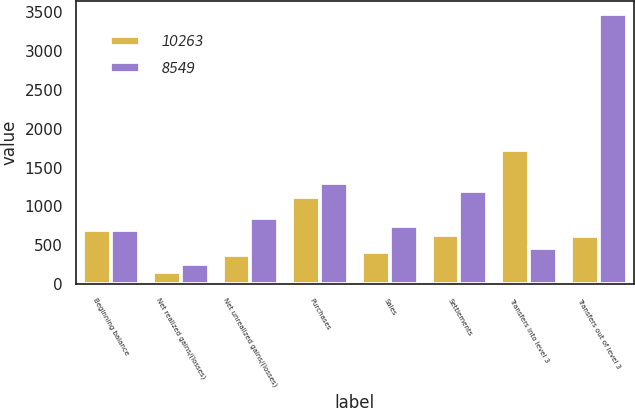Convert chart to OTSL. <chart><loc_0><loc_0><loc_500><loc_500><stacked_bar_chart><ecel><fcel>Beginning balance<fcel>Net realized gains/(losses)<fcel>Net unrealized gains/(losses)<fcel>Purchases<fcel>Sales<fcel>Settlements<fcel>Transfers into level 3<fcel>Transfers out of level 3<nl><fcel>10263<fcel>689<fcel>158<fcel>371<fcel>1122<fcel>412<fcel>634<fcel>1732<fcel>623<nl><fcel>8549<fcel>689<fcel>251<fcel>844<fcel>1295<fcel>744<fcel>1193<fcel>466<fcel>3478<nl></chart> 